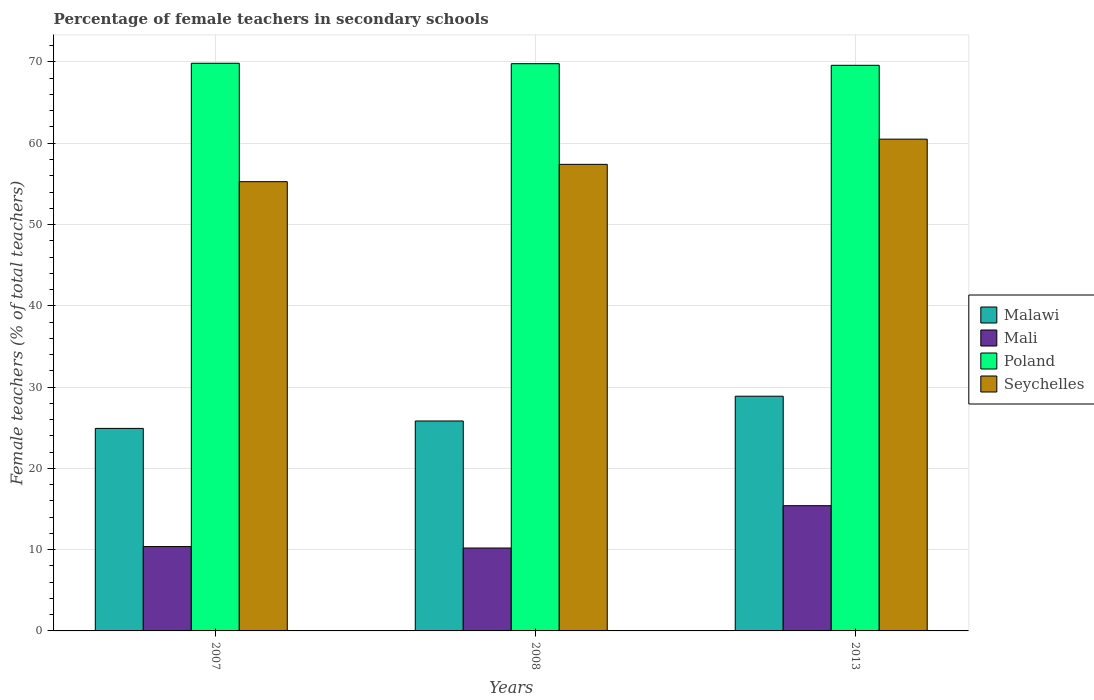How many groups of bars are there?
Your response must be concise. 3. How many bars are there on the 2nd tick from the right?
Offer a very short reply. 4. What is the label of the 2nd group of bars from the left?
Offer a terse response. 2008. What is the percentage of female teachers in Seychelles in 2007?
Your answer should be very brief. 55.27. Across all years, what is the maximum percentage of female teachers in Seychelles?
Provide a short and direct response. 60.5. Across all years, what is the minimum percentage of female teachers in Poland?
Keep it short and to the point. 69.59. In which year was the percentage of female teachers in Mali minimum?
Your answer should be very brief. 2008. What is the total percentage of female teachers in Malawi in the graph?
Keep it short and to the point. 79.62. What is the difference between the percentage of female teachers in Malawi in 2007 and that in 2013?
Provide a succinct answer. -3.96. What is the difference between the percentage of female teachers in Mali in 2007 and the percentage of female teachers in Malawi in 2008?
Provide a short and direct response. -15.45. What is the average percentage of female teachers in Seychelles per year?
Your answer should be very brief. 57.73. In the year 2007, what is the difference between the percentage of female teachers in Malawi and percentage of female teachers in Seychelles?
Keep it short and to the point. -30.35. What is the ratio of the percentage of female teachers in Seychelles in 2007 to that in 2013?
Make the answer very short. 0.91. What is the difference between the highest and the second highest percentage of female teachers in Mali?
Keep it short and to the point. 5.03. What is the difference between the highest and the lowest percentage of female teachers in Malawi?
Offer a terse response. 3.96. In how many years, is the percentage of female teachers in Seychelles greater than the average percentage of female teachers in Seychelles taken over all years?
Your answer should be very brief. 1. Is the sum of the percentage of female teachers in Seychelles in 2007 and 2008 greater than the maximum percentage of female teachers in Mali across all years?
Offer a very short reply. Yes. Is it the case that in every year, the sum of the percentage of female teachers in Mali and percentage of female teachers in Malawi is greater than the sum of percentage of female teachers in Poland and percentage of female teachers in Seychelles?
Give a very brief answer. No. What does the 2nd bar from the left in 2013 represents?
Offer a terse response. Mali. Are all the bars in the graph horizontal?
Your answer should be very brief. No. Does the graph contain grids?
Offer a terse response. Yes. How many legend labels are there?
Offer a very short reply. 4. How are the legend labels stacked?
Keep it short and to the point. Vertical. What is the title of the graph?
Provide a short and direct response. Percentage of female teachers in secondary schools. Does "Other small states" appear as one of the legend labels in the graph?
Your answer should be very brief. No. What is the label or title of the X-axis?
Your response must be concise. Years. What is the label or title of the Y-axis?
Make the answer very short. Female teachers (% of total teachers). What is the Female teachers (% of total teachers) of Malawi in 2007?
Offer a terse response. 24.92. What is the Female teachers (% of total teachers) in Mali in 2007?
Keep it short and to the point. 10.38. What is the Female teachers (% of total teachers) in Poland in 2007?
Provide a short and direct response. 69.84. What is the Female teachers (% of total teachers) in Seychelles in 2007?
Keep it short and to the point. 55.27. What is the Female teachers (% of total teachers) of Malawi in 2008?
Make the answer very short. 25.83. What is the Female teachers (% of total teachers) of Mali in 2008?
Ensure brevity in your answer.  10.2. What is the Female teachers (% of total teachers) in Poland in 2008?
Provide a short and direct response. 69.79. What is the Female teachers (% of total teachers) in Seychelles in 2008?
Keep it short and to the point. 57.4. What is the Female teachers (% of total teachers) in Malawi in 2013?
Ensure brevity in your answer.  28.88. What is the Female teachers (% of total teachers) in Mali in 2013?
Offer a terse response. 15.41. What is the Female teachers (% of total teachers) of Poland in 2013?
Give a very brief answer. 69.59. What is the Female teachers (% of total teachers) in Seychelles in 2013?
Keep it short and to the point. 60.5. Across all years, what is the maximum Female teachers (% of total teachers) in Malawi?
Your response must be concise. 28.88. Across all years, what is the maximum Female teachers (% of total teachers) in Mali?
Offer a very short reply. 15.41. Across all years, what is the maximum Female teachers (% of total teachers) of Poland?
Make the answer very short. 69.84. Across all years, what is the maximum Female teachers (% of total teachers) in Seychelles?
Your response must be concise. 60.5. Across all years, what is the minimum Female teachers (% of total teachers) of Malawi?
Offer a very short reply. 24.92. Across all years, what is the minimum Female teachers (% of total teachers) of Mali?
Keep it short and to the point. 10.2. Across all years, what is the minimum Female teachers (% of total teachers) of Poland?
Offer a very short reply. 69.59. Across all years, what is the minimum Female teachers (% of total teachers) of Seychelles?
Keep it short and to the point. 55.27. What is the total Female teachers (% of total teachers) in Malawi in the graph?
Offer a very short reply. 79.62. What is the total Female teachers (% of total teachers) in Mali in the graph?
Offer a terse response. 35.98. What is the total Female teachers (% of total teachers) of Poland in the graph?
Ensure brevity in your answer.  209.22. What is the total Female teachers (% of total teachers) in Seychelles in the graph?
Ensure brevity in your answer.  173.18. What is the difference between the Female teachers (% of total teachers) in Malawi in 2007 and that in 2008?
Offer a terse response. -0.91. What is the difference between the Female teachers (% of total teachers) of Mali in 2007 and that in 2008?
Provide a short and direct response. 0.18. What is the difference between the Female teachers (% of total teachers) in Poland in 2007 and that in 2008?
Your answer should be very brief. 0.05. What is the difference between the Female teachers (% of total teachers) in Seychelles in 2007 and that in 2008?
Keep it short and to the point. -2.13. What is the difference between the Female teachers (% of total teachers) of Malawi in 2007 and that in 2013?
Give a very brief answer. -3.96. What is the difference between the Female teachers (% of total teachers) of Mali in 2007 and that in 2013?
Offer a terse response. -5.03. What is the difference between the Female teachers (% of total teachers) of Poland in 2007 and that in 2013?
Offer a terse response. 0.25. What is the difference between the Female teachers (% of total teachers) of Seychelles in 2007 and that in 2013?
Your response must be concise. -5.23. What is the difference between the Female teachers (% of total teachers) in Malawi in 2008 and that in 2013?
Keep it short and to the point. -3.05. What is the difference between the Female teachers (% of total teachers) of Mali in 2008 and that in 2013?
Offer a terse response. -5.21. What is the difference between the Female teachers (% of total teachers) in Poland in 2008 and that in 2013?
Provide a succinct answer. 0.2. What is the difference between the Female teachers (% of total teachers) of Seychelles in 2008 and that in 2013?
Provide a short and direct response. -3.1. What is the difference between the Female teachers (% of total teachers) of Malawi in 2007 and the Female teachers (% of total teachers) of Mali in 2008?
Make the answer very short. 14.72. What is the difference between the Female teachers (% of total teachers) of Malawi in 2007 and the Female teachers (% of total teachers) of Poland in 2008?
Your response must be concise. -44.87. What is the difference between the Female teachers (% of total teachers) in Malawi in 2007 and the Female teachers (% of total teachers) in Seychelles in 2008?
Give a very brief answer. -32.49. What is the difference between the Female teachers (% of total teachers) in Mali in 2007 and the Female teachers (% of total teachers) in Poland in 2008?
Keep it short and to the point. -59.41. What is the difference between the Female teachers (% of total teachers) of Mali in 2007 and the Female teachers (% of total teachers) of Seychelles in 2008?
Your answer should be very brief. -47.03. What is the difference between the Female teachers (% of total teachers) of Poland in 2007 and the Female teachers (% of total teachers) of Seychelles in 2008?
Offer a terse response. 12.44. What is the difference between the Female teachers (% of total teachers) in Malawi in 2007 and the Female teachers (% of total teachers) in Mali in 2013?
Provide a short and direct response. 9.51. What is the difference between the Female teachers (% of total teachers) of Malawi in 2007 and the Female teachers (% of total teachers) of Poland in 2013?
Ensure brevity in your answer.  -44.67. What is the difference between the Female teachers (% of total teachers) in Malawi in 2007 and the Female teachers (% of total teachers) in Seychelles in 2013?
Make the answer very short. -35.59. What is the difference between the Female teachers (% of total teachers) of Mali in 2007 and the Female teachers (% of total teachers) of Poland in 2013?
Offer a very short reply. -59.21. What is the difference between the Female teachers (% of total teachers) of Mali in 2007 and the Female teachers (% of total teachers) of Seychelles in 2013?
Your answer should be compact. -50.13. What is the difference between the Female teachers (% of total teachers) of Poland in 2007 and the Female teachers (% of total teachers) of Seychelles in 2013?
Your response must be concise. 9.34. What is the difference between the Female teachers (% of total teachers) of Malawi in 2008 and the Female teachers (% of total teachers) of Mali in 2013?
Give a very brief answer. 10.42. What is the difference between the Female teachers (% of total teachers) of Malawi in 2008 and the Female teachers (% of total teachers) of Poland in 2013?
Make the answer very short. -43.76. What is the difference between the Female teachers (% of total teachers) in Malawi in 2008 and the Female teachers (% of total teachers) in Seychelles in 2013?
Provide a succinct answer. -34.67. What is the difference between the Female teachers (% of total teachers) in Mali in 2008 and the Female teachers (% of total teachers) in Poland in 2013?
Provide a succinct answer. -59.39. What is the difference between the Female teachers (% of total teachers) in Mali in 2008 and the Female teachers (% of total teachers) in Seychelles in 2013?
Keep it short and to the point. -50.3. What is the difference between the Female teachers (% of total teachers) in Poland in 2008 and the Female teachers (% of total teachers) in Seychelles in 2013?
Your response must be concise. 9.28. What is the average Female teachers (% of total teachers) of Malawi per year?
Make the answer very short. 26.54. What is the average Female teachers (% of total teachers) of Mali per year?
Ensure brevity in your answer.  11.99. What is the average Female teachers (% of total teachers) of Poland per year?
Provide a succinct answer. 69.74. What is the average Female teachers (% of total teachers) of Seychelles per year?
Offer a very short reply. 57.73. In the year 2007, what is the difference between the Female teachers (% of total teachers) in Malawi and Female teachers (% of total teachers) in Mali?
Provide a short and direct response. 14.54. In the year 2007, what is the difference between the Female teachers (% of total teachers) in Malawi and Female teachers (% of total teachers) in Poland?
Your answer should be very brief. -44.92. In the year 2007, what is the difference between the Female teachers (% of total teachers) in Malawi and Female teachers (% of total teachers) in Seychelles?
Your answer should be compact. -30.35. In the year 2007, what is the difference between the Female teachers (% of total teachers) of Mali and Female teachers (% of total teachers) of Poland?
Ensure brevity in your answer.  -59.47. In the year 2007, what is the difference between the Female teachers (% of total teachers) of Mali and Female teachers (% of total teachers) of Seychelles?
Offer a terse response. -44.9. In the year 2007, what is the difference between the Female teachers (% of total teachers) of Poland and Female teachers (% of total teachers) of Seychelles?
Offer a terse response. 14.57. In the year 2008, what is the difference between the Female teachers (% of total teachers) of Malawi and Female teachers (% of total teachers) of Mali?
Keep it short and to the point. 15.63. In the year 2008, what is the difference between the Female teachers (% of total teachers) in Malawi and Female teachers (% of total teachers) in Poland?
Your answer should be very brief. -43.96. In the year 2008, what is the difference between the Female teachers (% of total teachers) of Malawi and Female teachers (% of total teachers) of Seychelles?
Your response must be concise. -31.57. In the year 2008, what is the difference between the Female teachers (% of total teachers) in Mali and Female teachers (% of total teachers) in Poland?
Offer a very short reply. -59.59. In the year 2008, what is the difference between the Female teachers (% of total teachers) in Mali and Female teachers (% of total teachers) in Seychelles?
Ensure brevity in your answer.  -47.2. In the year 2008, what is the difference between the Female teachers (% of total teachers) in Poland and Female teachers (% of total teachers) in Seychelles?
Your answer should be very brief. 12.38. In the year 2013, what is the difference between the Female teachers (% of total teachers) of Malawi and Female teachers (% of total teachers) of Mali?
Your answer should be very brief. 13.47. In the year 2013, what is the difference between the Female teachers (% of total teachers) in Malawi and Female teachers (% of total teachers) in Poland?
Offer a terse response. -40.71. In the year 2013, what is the difference between the Female teachers (% of total teachers) in Malawi and Female teachers (% of total teachers) in Seychelles?
Make the answer very short. -31.63. In the year 2013, what is the difference between the Female teachers (% of total teachers) of Mali and Female teachers (% of total teachers) of Poland?
Your answer should be compact. -54.18. In the year 2013, what is the difference between the Female teachers (% of total teachers) in Mali and Female teachers (% of total teachers) in Seychelles?
Your answer should be very brief. -45.1. In the year 2013, what is the difference between the Female teachers (% of total teachers) in Poland and Female teachers (% of total teachers) in Seychelles?
Provide a succinct answer. 9.09. What is the ratio of the Female teachers (% of total teachers) in Malawi in 2007 to that in 2008?
Offer a very short reply. 0.96. What is the ratio of the Female teachers (% of total teachers) in Mali in 2007 to that in 2008?
Make the answer very short. 1.02. What is the ratio of the Female teachers (% of total teachers) in Seychelles in 2007 to that in 2008?
Offer a terse response. 0.96. What is the ratio of the Female teachers (% of total teachers) of Malawi in 2007 to that in 2013?
Your answer should be very brief. 0.86. What is the ratio of the Female teachers (% of total teachers) in Mali in 2007 to that in 2013?
Offer a very short reply. 0.67. What is the ratio of the Female teachers (% of total teachers) in Poland in 2007 to that in 2013?
Provide a succinct answer. 1. What is the ratio of the Female teachers (% of total teachers) of Seychelles in 2007 to that in 2013?
Keep it short and to the point. 0.91. What is the ratio of the Female teachers (% of total teachers) of Malawi in 2008 to that in 2013?
Provide a short and direct response. 0.89. What is the ratio of the Female teachers (% of total teachers) in Mali in 2008 to that in 2013?
Give a very brief answer. 0.66. What is the ratio of the Female teachers (% of total teachers) of Poland in 2008 to that in 2013?
Offer a very short reply. 1. What is the ratio of the Female teachers (% of total teachers) in Seychelles in 2008 to that in 2013?
Make the answer very short. 0.95. What is the difference between the highest and the second highest Female teachers (% of total teachers) of Malawi?
Offer a terse response. 3.05. What is the difference between the highest and the second highest Female teachers (% of total teachers) in Mali?
Your answer should be very brief. 5.03. What is the difference between the highest and the second highest Female teachers (% of total teachers) of Poland?
Offer a very short reply. 0.05. What is the difference between the highest and the second highest Female teachers (% of total teachers) in Seychelles?
Keep it short and to the point. 3.1. What is the difference between the highest and the lowest Female teachers (% of total teachers) of Malawi?
Keep it short and to the point. 3.96. What is the difference between the highest and the lowest Female teachers (% of total teachers) of Mali?
Keep it short and to the point. 5.21. What is the difference between the highest and the lowest Female teachers (% of total teachers) of Poland?
Make the answer very short. 0.25. What is the difference between the highest and the lowest Female teachers (% of total teachers) of Seychelles?
Your response must be concise. 5.23. 